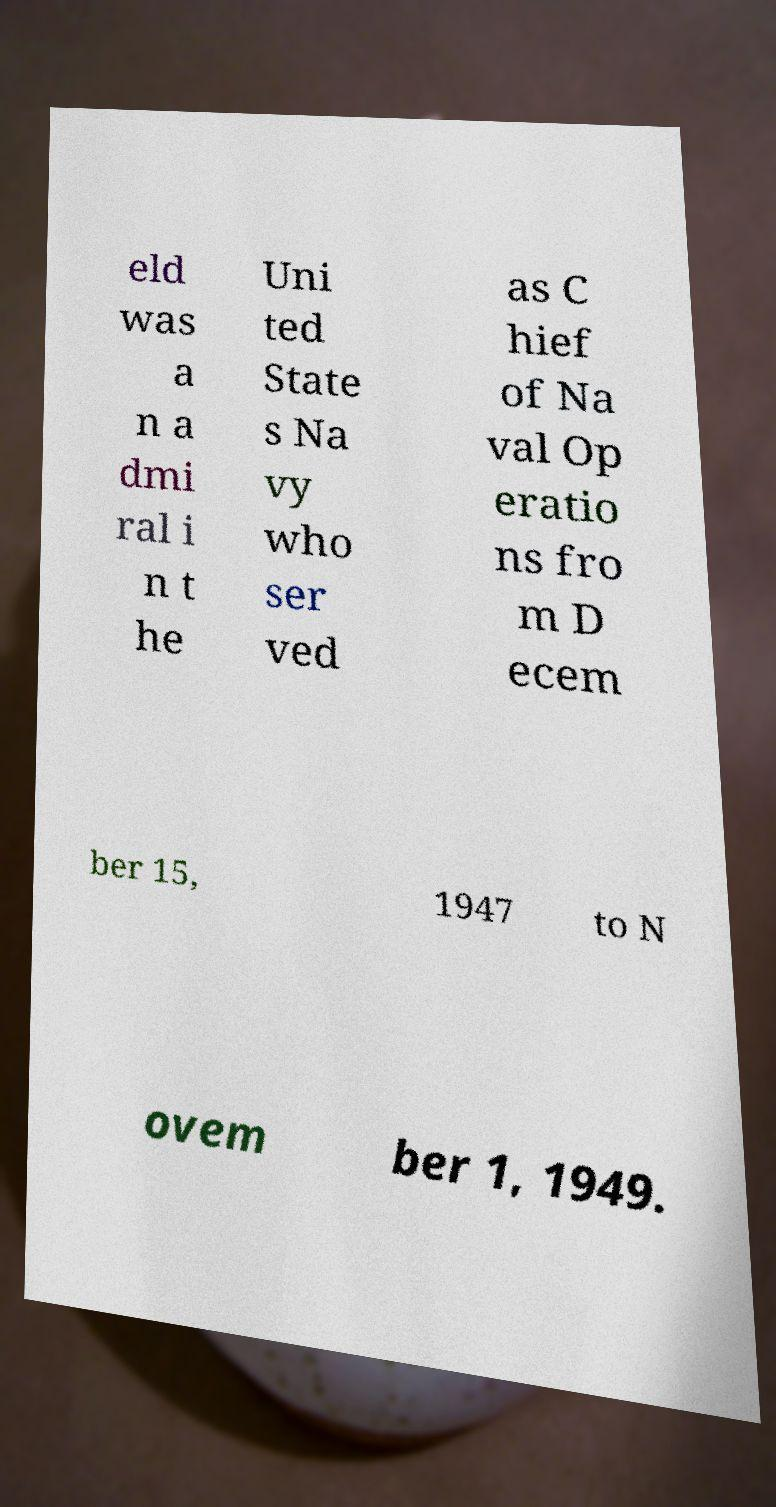Can you read and provide the text displayed in the image?This photo seems to have some interesting text. Can you extract and type it out for me? eld was a n a dmi ral i n t he Uni ted State s Na vy who ser ved as C hief of Na val Op eratio ns fro m D ecem ber 15, 1947 to N ovem ber 1, 1949. 